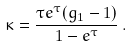Convert formula to latex. <formula><loc_0><loc_0><loc_500><loc_500>\kappa = \frac { \tau e ^ { \tau } ( g _ { 1 } - 1 ) } { 1 - e ^ { \tau } } \, .</formula> 